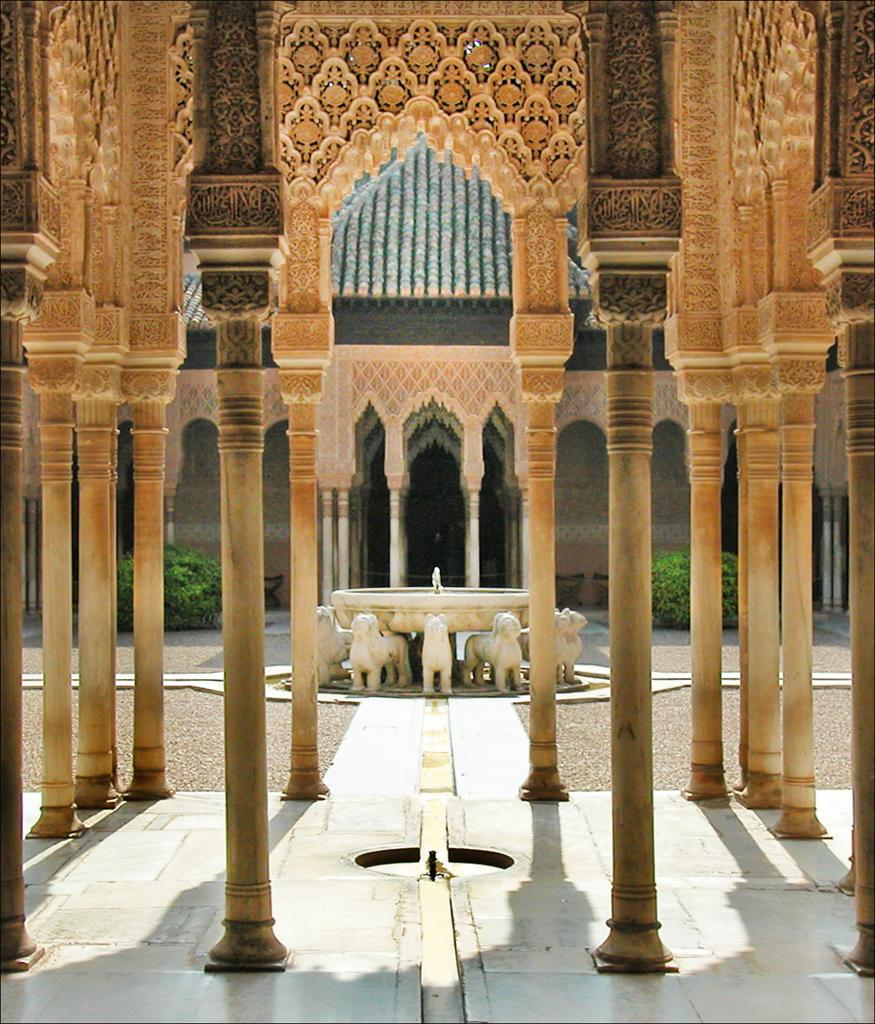What type of building is depicted in the image? The image is of a palace. Can you describe any specific architectural features of the palace? The provided facts do not mention any specific architectural features of the palace. What is the surrounding environment of the palace like? The provided facts do not mention the surrounding environment of the palace. What type of line is used to hold the liquid in the image? There is no mention of a line or liquid in the image, as it is of a palace. 